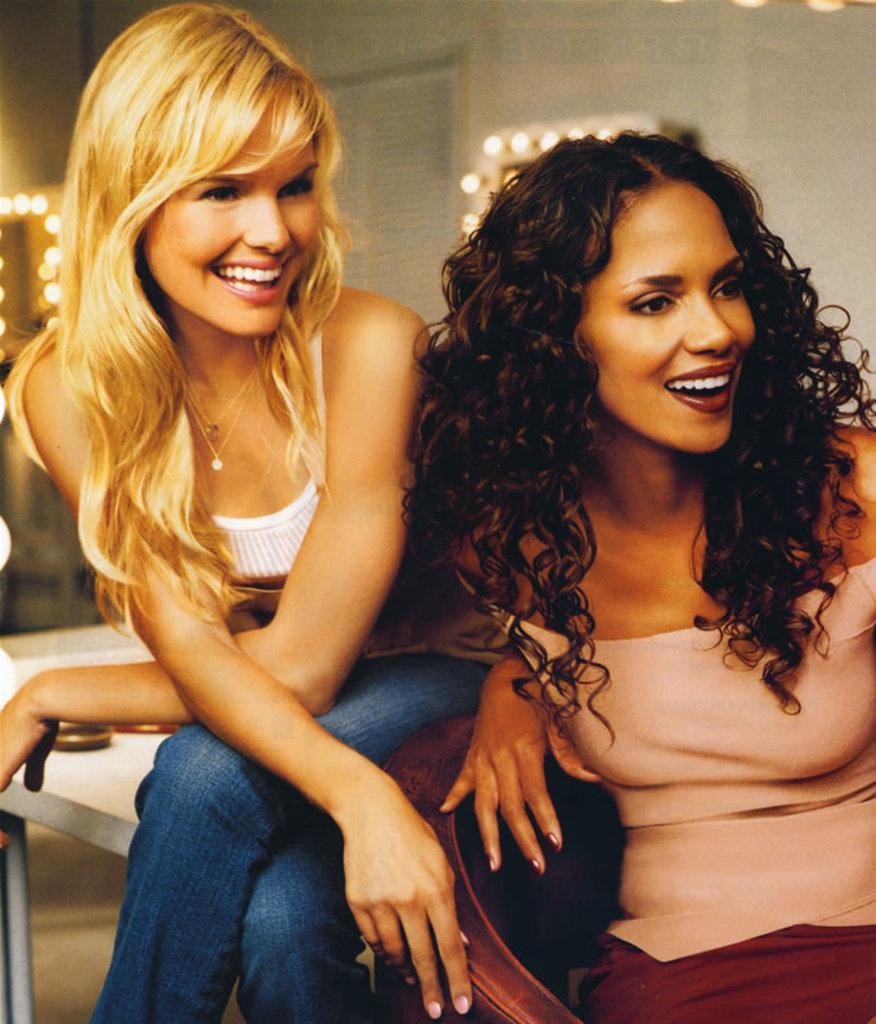Describe this image in one or two sentences. This image consists of two women sitting. To the left, the woman is sitting on the table. To the right, the woman is sitting in the chair. In the background, there is a wall along with lights. 